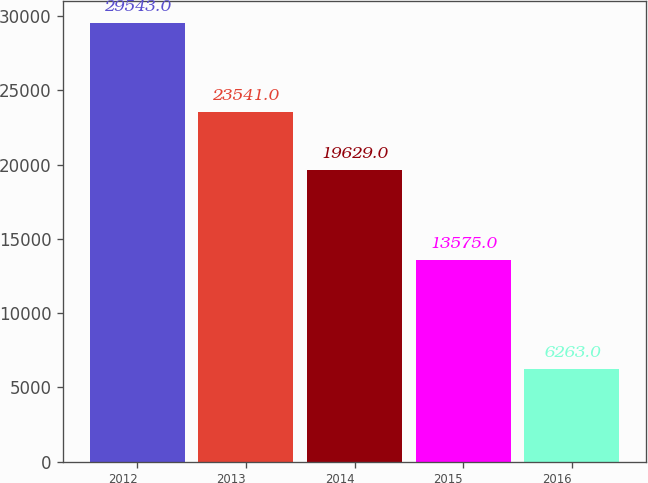Convert chart. <chart><loc_0><loc_0><loc_500><loc_500><bar_chart><fcel>2012<fcel>2013<fcel>2014<fcel>2015<fcel>2016<nl><fcel>29543<fcel>23541<fcel>19629<fcel>13575<fcel>6263<nl></chart> 